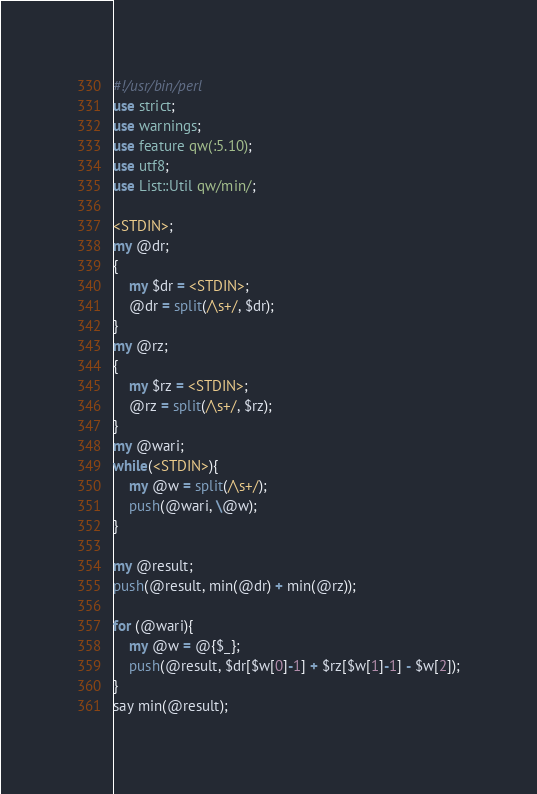<code> <loc_0><loc_0><loc_500><loc_500><_Perl_>#!/usr/bin/perl
use strict;
use warnings;
use feature qw(:5.10);
use utf8;
use List::Util qw/min/;

<STDIN>;
my @dr;
{
    my $dr = <STDIN>;
    @dr = split(/\s+/, $dr);
}
my @rz;
{
    my $rz = <STDIN>;
    @rz = split(/\s+/, $rz);
}
my @wari;
while(<STDIN>){
    my @w = split(/\s+/);
    push(@wari, \@w);
}

my @result;
push(@result, min(@dr) + min(@rz));

for (@wari){
    my @w = @{$_};
    push(@result, $dr[$w[0]-1] + $rz[$w[1]-1] - $w[2]);
}
say min(@result);
</code> 